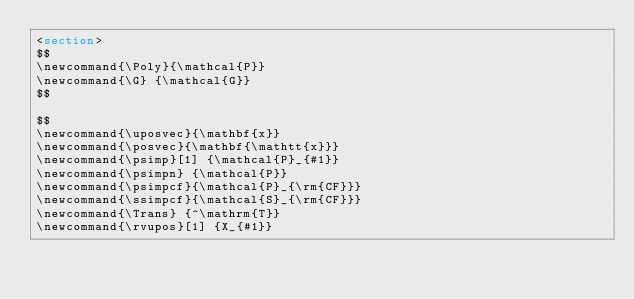<code> <loc_0><loc_0><loc_500><loc_500><_HTML_><section>		
$$ 
\newcommand{\Poly}{\mathcal{P}}
\newcommand{\G} {\mathcal{G}}
$$

$$
\newcommand{\uposvec}{\mathbf{x}}
\newcommand{\posvec}{\mathbf{\mathtt{x}}}
\newcommand{\psimp}[1] {\mathcal{P}_{#1}} 
\newcommand{\psimpn} {\mathcal{P}} 
\newcommand{\psimpcf}{\mathcal{P}_{\rm{CF}}}
\newcommand{\ssimpcf}{\mathcal{S}_{\rm{CF}}}
\newcommand{\Trans} {^\mathrm{T}}
\newcommand{\rvupos}[1] {X_{#1}}</code> 